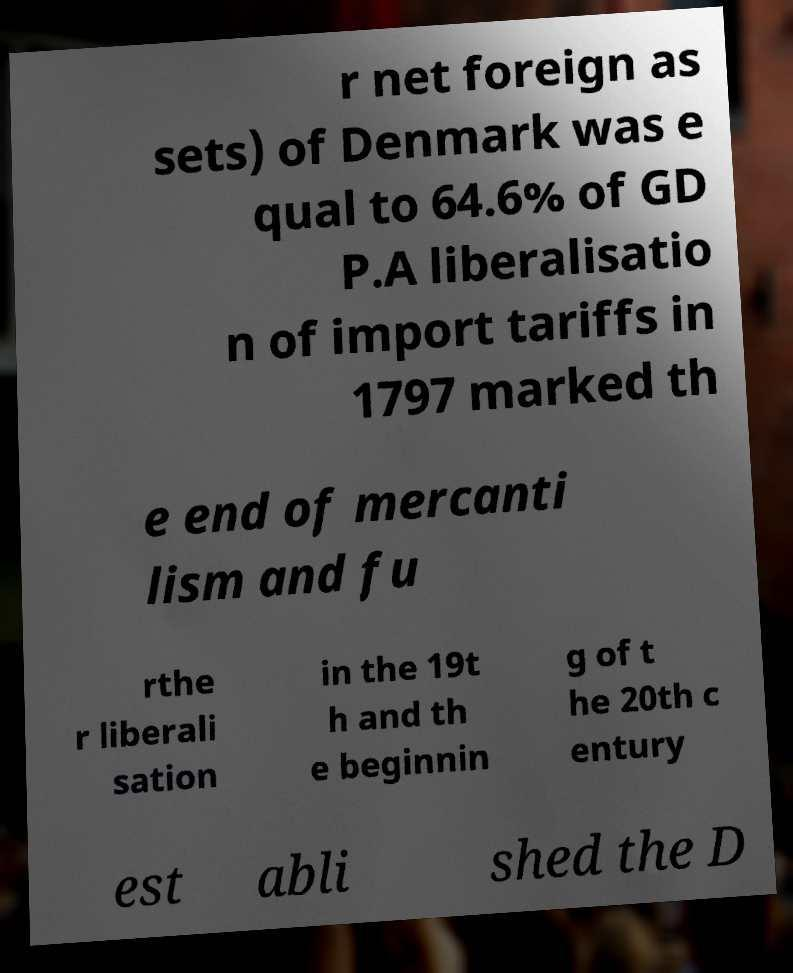Can you accurately transcribe the text from the provided image for me? r net foreign as sets) of Denmark was e qual to 64.6% of GD P.A liberalisatio n of import tariffs in 1797 marked th e end of mercanti lism and fu rthe r liberali sation in the 19t h and th e beginnin g of t he 20th c entury est abli shed the D 